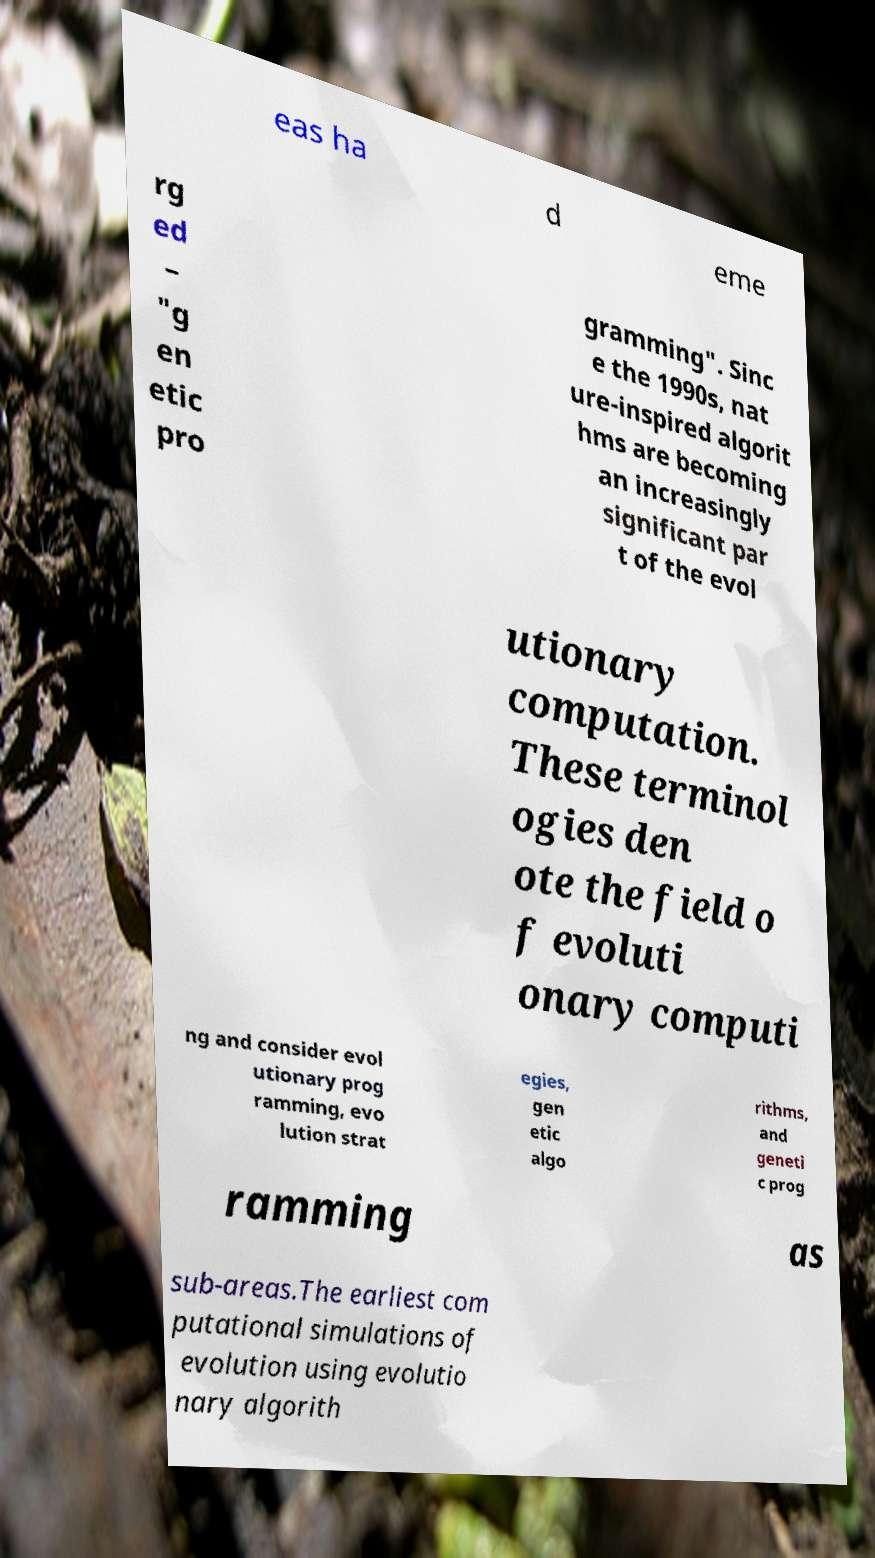Can you accurately transcribe the text from the provided image for me? eas ha d eme rg ed – "g en etic pro gramming". Sinc e the 1990s, nat ure-inspired algorit hms are becoming an increasingly significant par t of the evol utionary computation. These terminol ogies den ote the field o f evoluti onary computi ng and consider evol utionary prog ramming, evo lution strat egies, gen etic algo rithms, and geneti c prog ramming as sub-areas.The earliest com putational simulations of evolution using evolutio nary algorith 